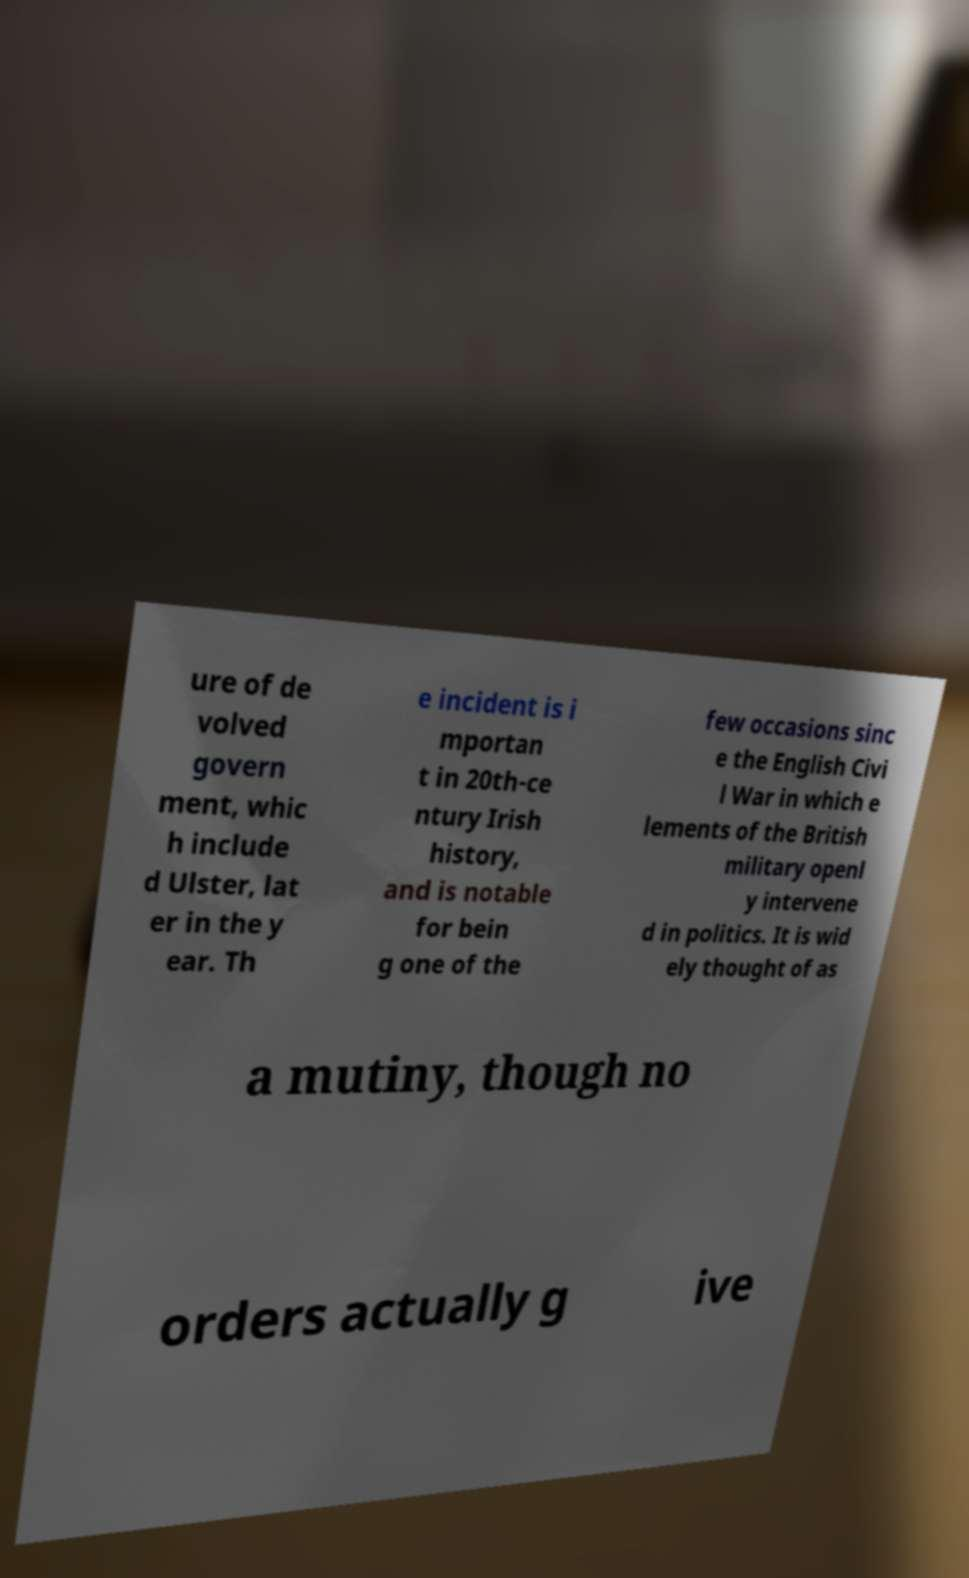Could you extract and type out the text from this image? ure of de volved govern ment, whic h include d Ulster, lat er in the y ear. Th e incident is i mportan t in 20th-ce ntury Irish history, and is notable for bein g one of the few occasions sinc e the English Civi l War in which e lements of the British military openl y intervene d in politics. It is wid ely thought of as a mutiny, though no orders actually g ive 